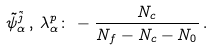<formula> <loc_0><loc_0><loc_500><loc_500>\tilde { \psi } ^ { \tilde { j } } _ { \alpha } \, , \, \lambda _ { \alpha } ^ { p } \colon \, - \frac { N _ { c } } { N _ { f } - N _ { c } - N _ { 0 } } \, .</formula> 